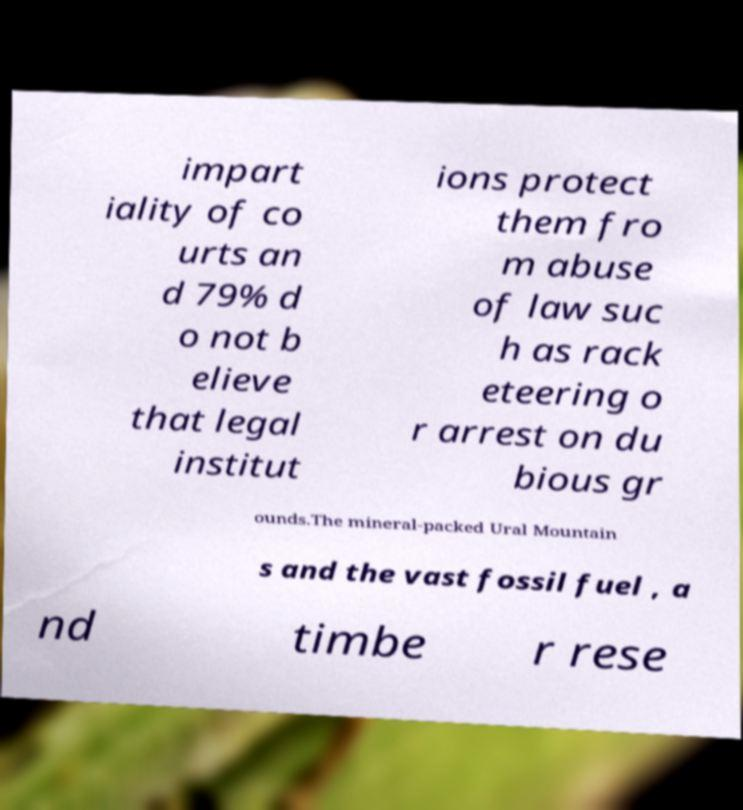Can you accurately transcribe the text from the provided image for me? impart iality of co urts an d 79% d o not b elieve that legal institut ions protect them fro m abuse of law suc h as rack eteering o r arrest on du bious gr ounds.The mineral-packed Ural Mountain s and the vast fossil fuel , a nd timbe r rese 